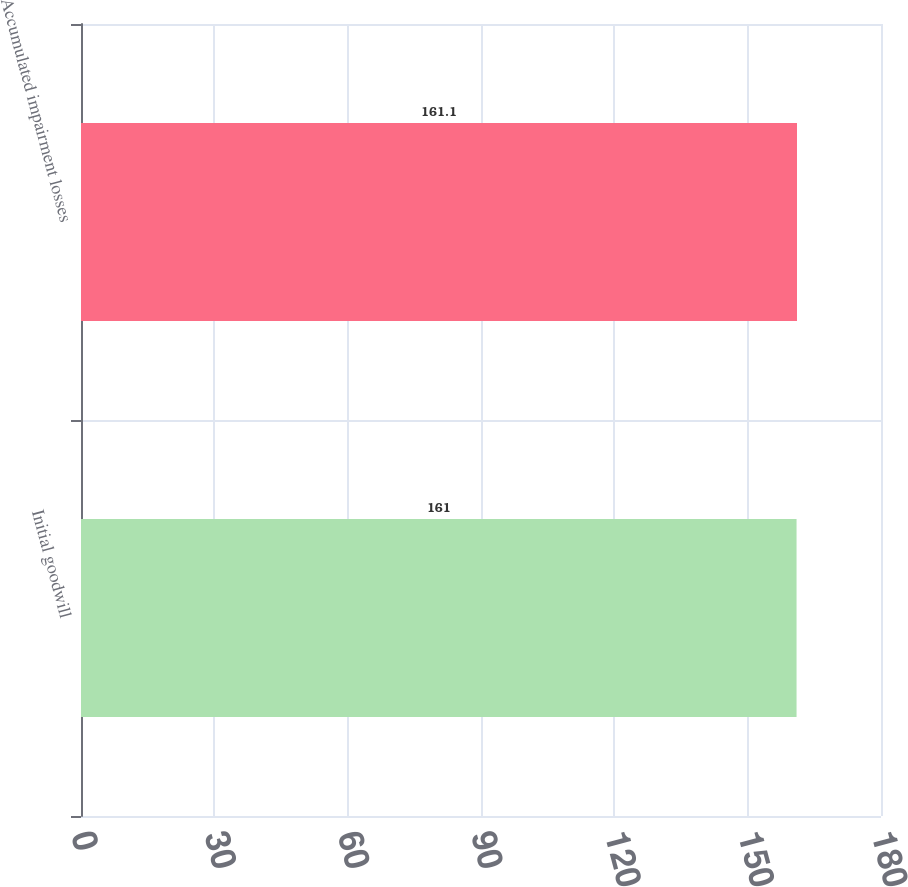<chart> <loc_0><loc_0><loc_500><loc_500><bar_chart><fcel>Initial goodwill<fcel>Accumulated impairment losses<nl><fcel>161<fcel>161.1<nl></chart> 